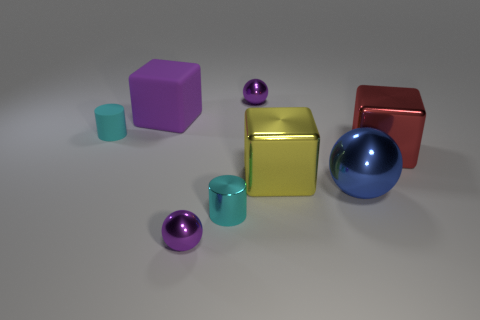There is a tiny purple shiny thing in front of the large purple block; does it have the same shape as the purple shiny thing behind the large blue shiny sphere?
Your response must be concise. Yes. Do the cyan rubber cylinder and the red thing have the same size?
Provide a short and direct response. No. What is the size of the red cube that is the same material as the blue sphere?
Provide a succinct answer. Large. Are there any other rubber things that have the same shape as the large yellow thing?
Ensure brevity in your answer.  Yes. Is there anything else of the same color as the big sphere?
Offer a very short reply. No. There is a blue object that is made of the same material as the red object; what shape is it?
Provide a succinct answer. Sphere. There is a ball that is to the right of the purple shiny object that is behind the tiny cyan cylinder that is behind the red metallic block; what is its color?
Give a very brief answer. Blue. Are there an equal number of yellow things that are right of the large yellow object and big brown things?
Ensure brevity in your answer.  Yes. Is there any other thing that is the same material as the big red block?
Ensure brevity in your answer.  Yes. There is a rubber cylinder; does it have the same color as the tiny sphere that is in front of the cyan rubber object?
Provide a succinct answer. No. 